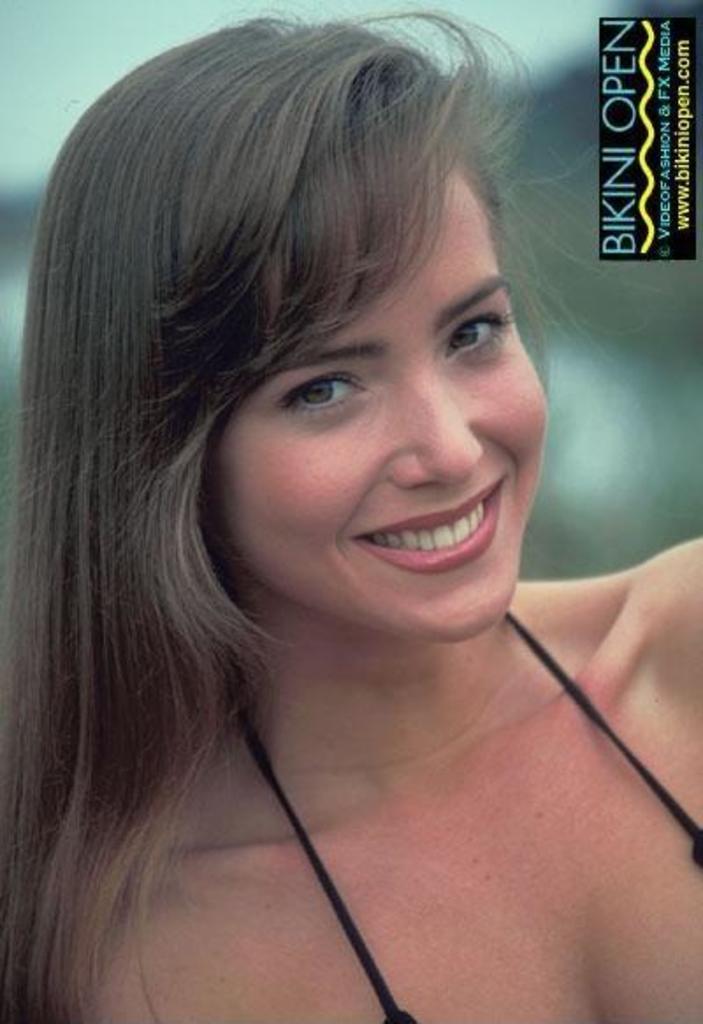Could you give a brief overview of what you see in this image? In this picture we can see a woman is smiling in the front, at the right top we can see some text, there is a blurry background. 